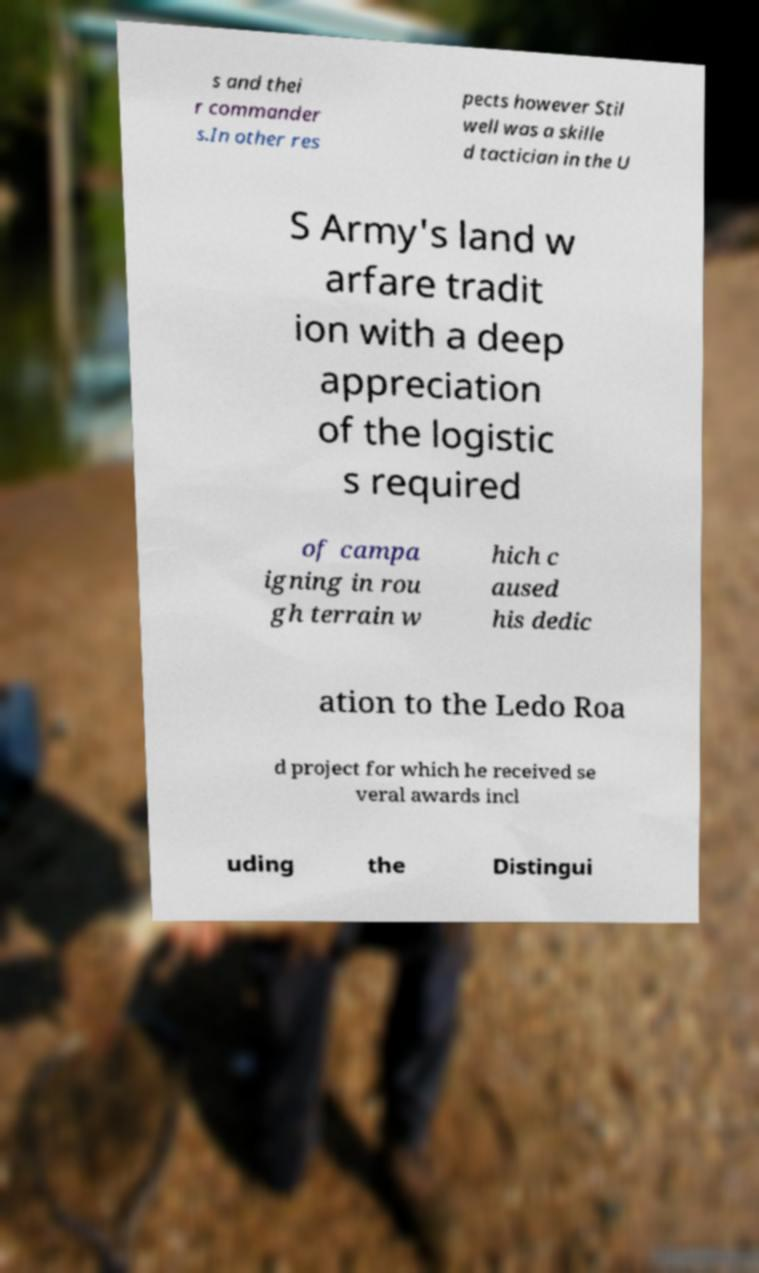Can you accurately transcribe the text from the provided image for me? s and thei r commander s.In other res pects however Stil well was a skille d tactician in the U S Army's land w arfare tradit ion with a deep appreciation of the logistic s required of campa igning in rou gh terrain w hich c aused his dedic ation to the Ledo Roa d project for which he received se veral awards incl uding the Distingui 